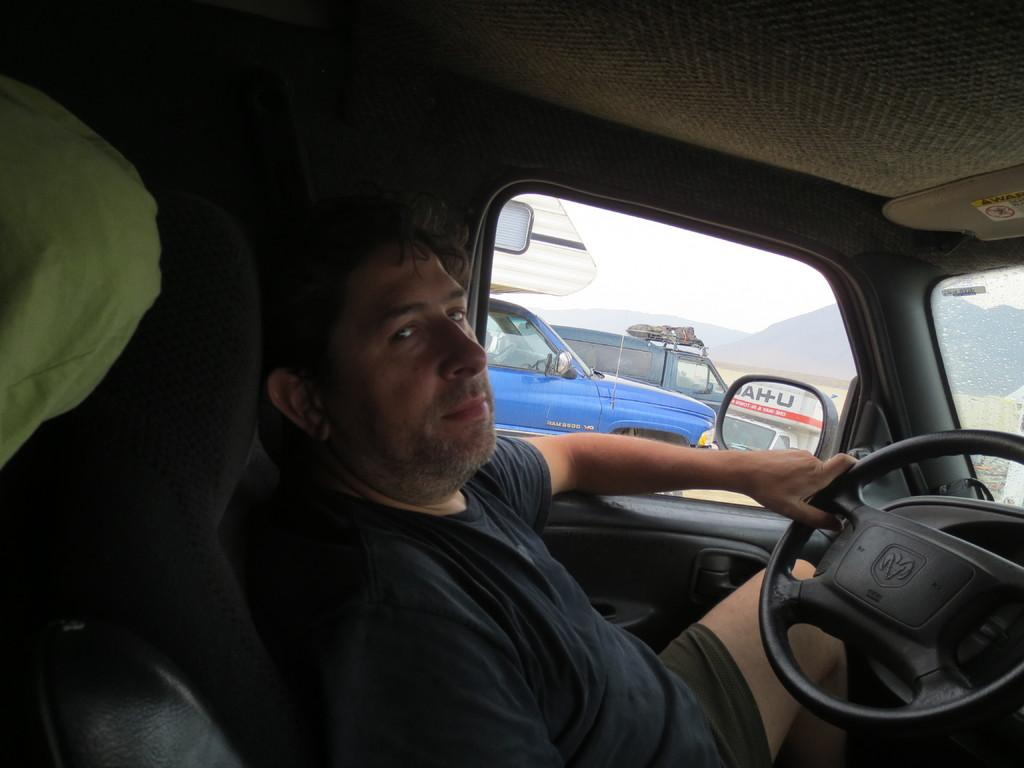Who is present in the image? There is a person in the image. What is the person wearing? The person is wearing a black dress. Where is the person located in the image? The person is sitting in a car. How many cars are visible in the image? There are three cars in total, including the person's car and two cars beside it. What type of ghost is haunting the person in the image? There is no ghost present in the image; it features a person sitting in a car. 